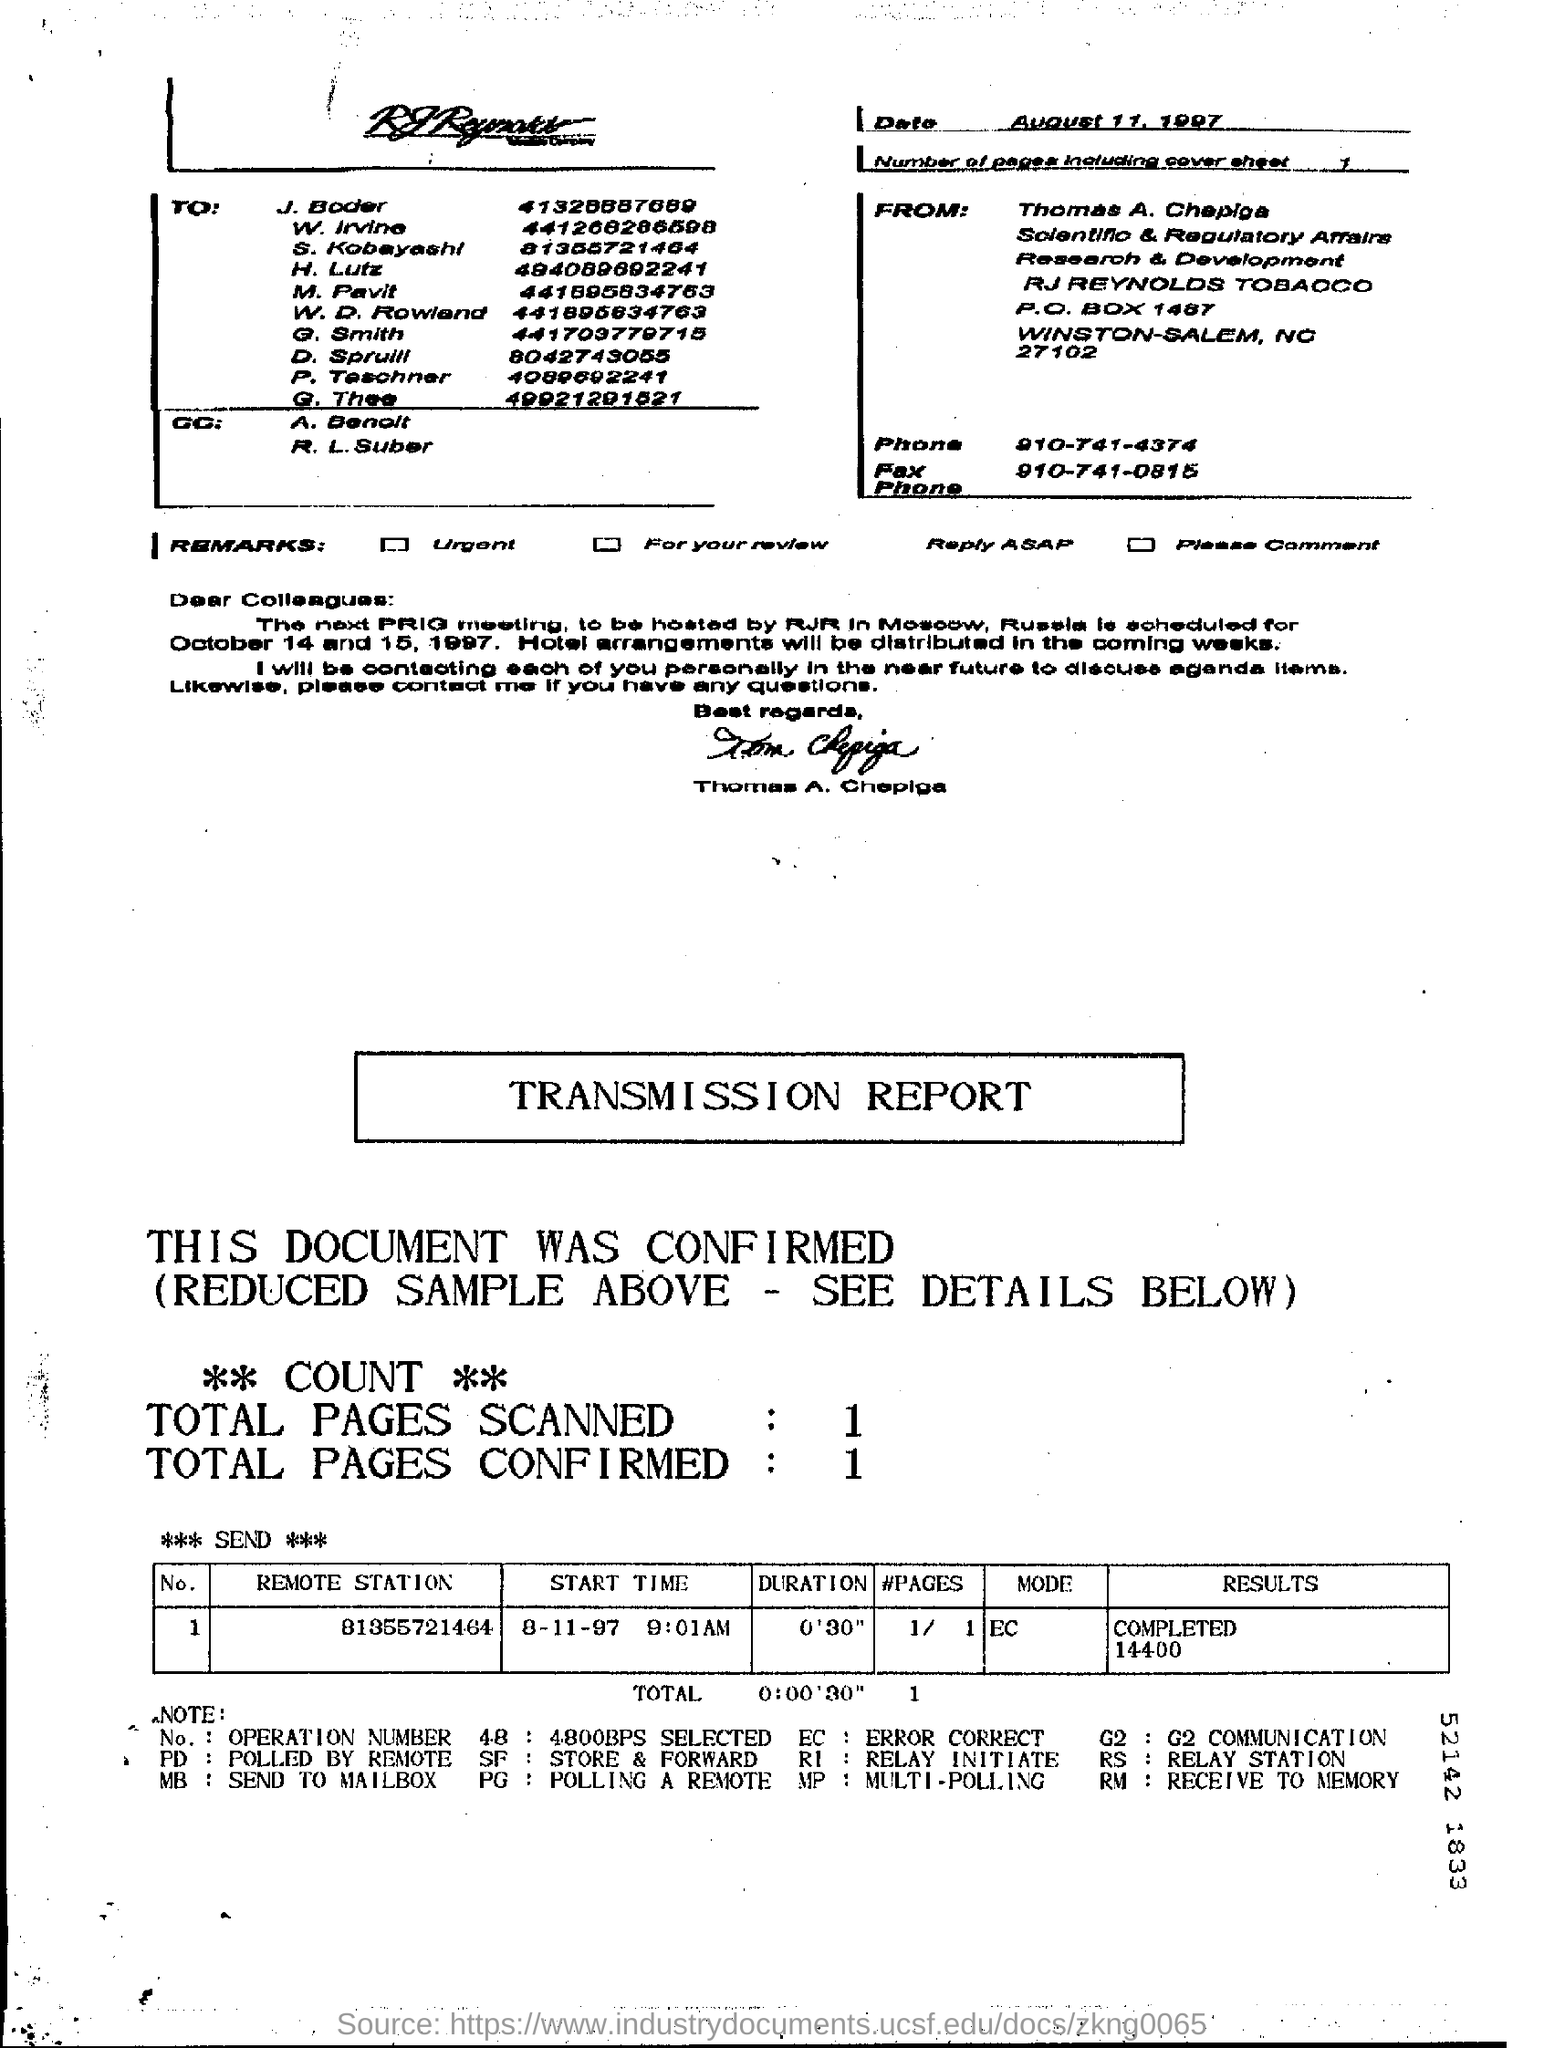Outline some significant characteristics in this image. There are one page in the fax, including the cover sheet. The phone number of Thomas A. Chepiga is 910-741-4374. The sender of the fax is Thomas A. Chepiga. 